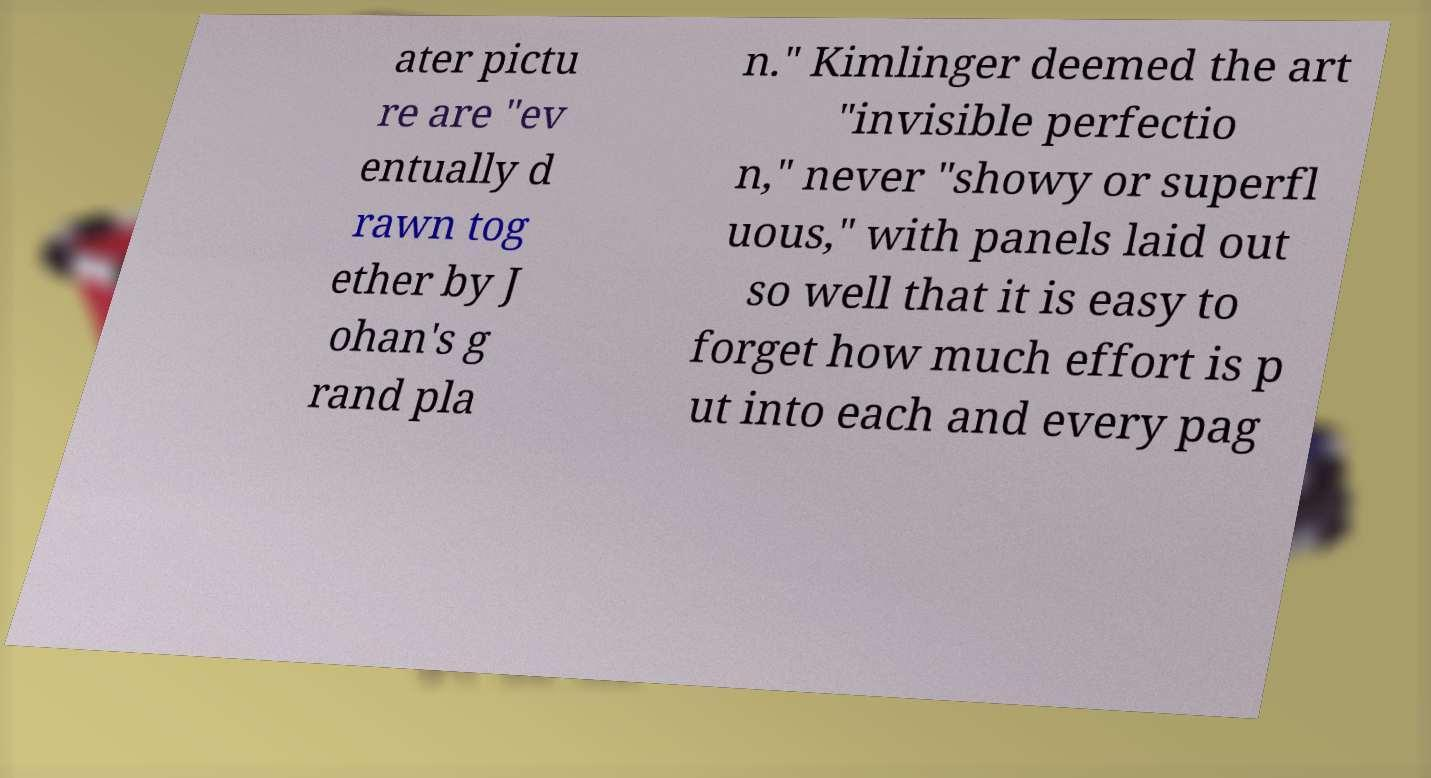I need the written content from this picture converted into text. Can you do that? ater pictu re are "ev entually d rawn tog ether by J ohan's g rand pla n." Kimlinger deemed the art "invisible perfectio n," never "showy or superfl uous," with panels laid out so well that it is easy to forget how much effort is p ut into each and every pag 